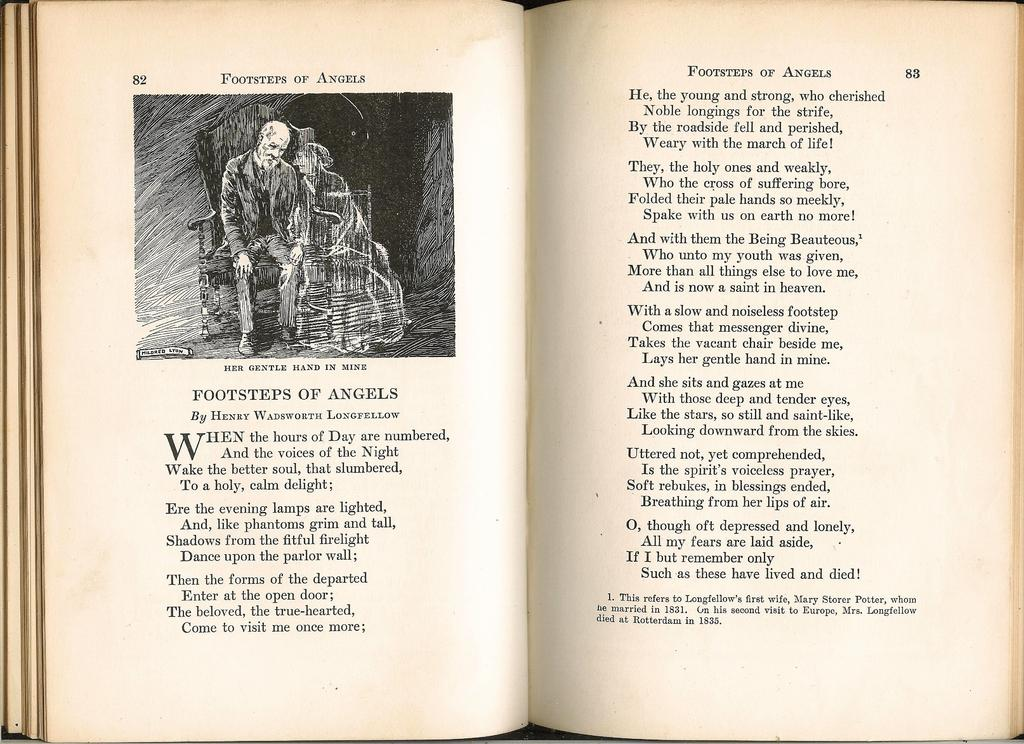<image>
Provide a brief description of the given image. an open book open to page 82 that says footsteps of angels at the top 